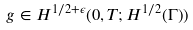Convert formula to latex. <formula><loc_0><loc_0><loc_500><loc_500>g \in H ^ { 1 / 2 + \epsilon } ( 0 , T ; H ^ { 1 / 2 } ( \Gamma ) )</formula> 